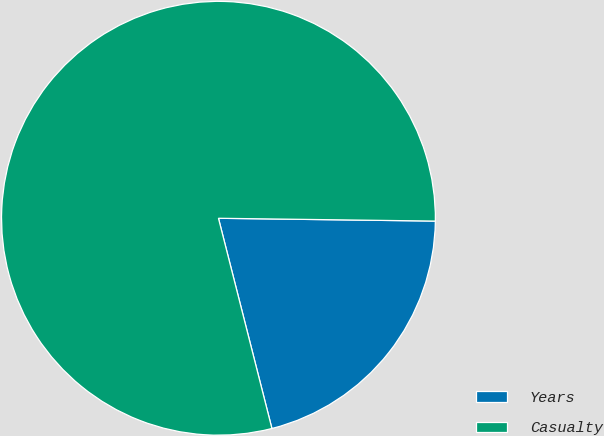<chart> <loc_0><loc_0><loc_500><loc_500><pie_chart><fcel>Years<fcel>Casualty<nl><fcel>20.83%<fcel>79.17%<nl></chart> 